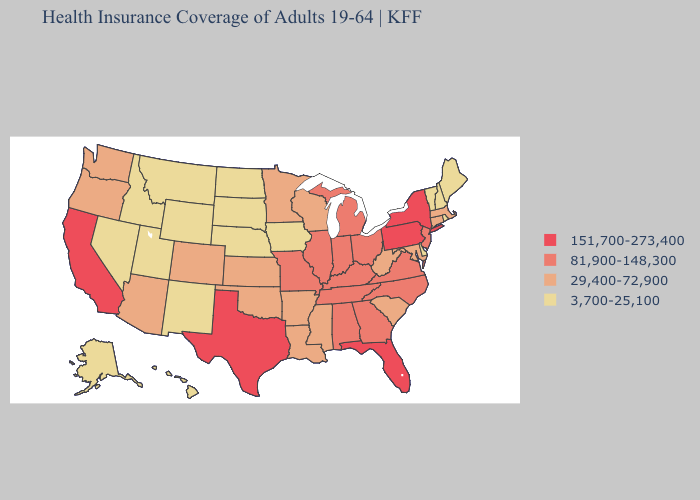Does Washington have the same value as Oklahoma?
Concise answer only. Yes. Does Colorado have the lowest value in the USA?
Write a very short answer. No. What is the value of Kansas?
Quick response, please. 29,400-72,900. Which states have the lowest value in the West?
Concise answer only. Alaska, Hawaii, Idaho, Montana, Nevada, New Mexico, Utah, Wyoming. What is the value of Oregon?
Short answer required. 29,400-72,900. What is the value of Ohio?
Be succinct. 81,900-148,300. What is the value of New York?
Quick response, please. 151,700-273,400. Among the states that border Mississippi , does Arkansas have the lowest value?
Keep it brief. Yes. Which states have the lowest value in the South?
Answer briefly. Delaware. What is the value of Mississippi?
Concise answer only. 29,400-72,900. Name the states that have a value in the range 29,400-72,900?
Be succinct. Arizona, Arkansas, Colorado, Connecticut, Kansas, Louisiana, Maryland, Massachusetts, Minnesota, Mississippi, Oklahoma, Oregon, South Carolina, Washington, West Virginia, Wisconsin. What is the value of Ohio?
Concise answer only. 81,900-148,300. Name the states that have a value in the range 151,700-273,400?
Be succinct. California, Florida, New York, Pennsylvania, Texas. Does Tennessee have the lowest value in the USA?
Write a very short answer. No. Which states hav the highest value in the West?
Concise answer only. California. 